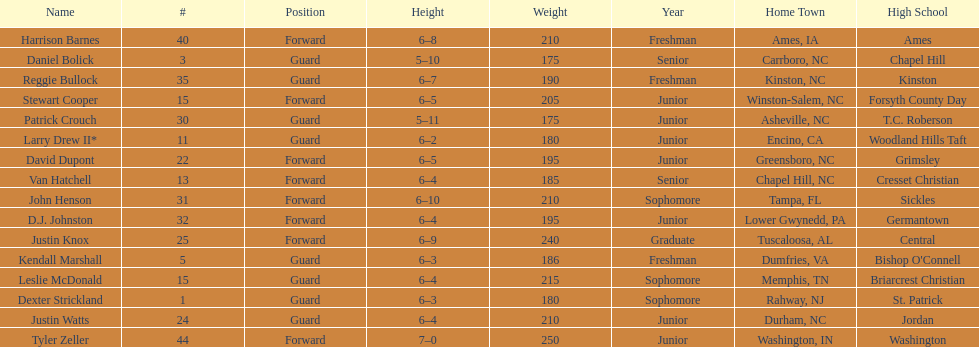What was the number of freshmen on the team? 3. 